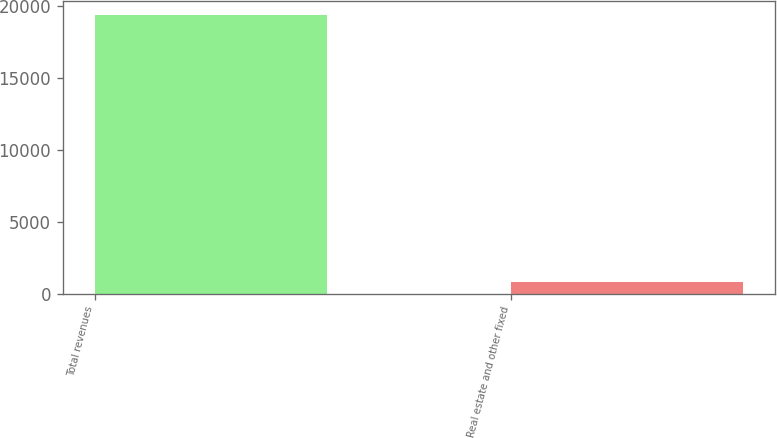Convert chart. <chart><loc_0><loc_0><loc_500><loc_500><bar_chart><fcel>Total revenues<fcel>Real estate and other fixed<nl><fcel>19383<fcel>790<nl></chart> 